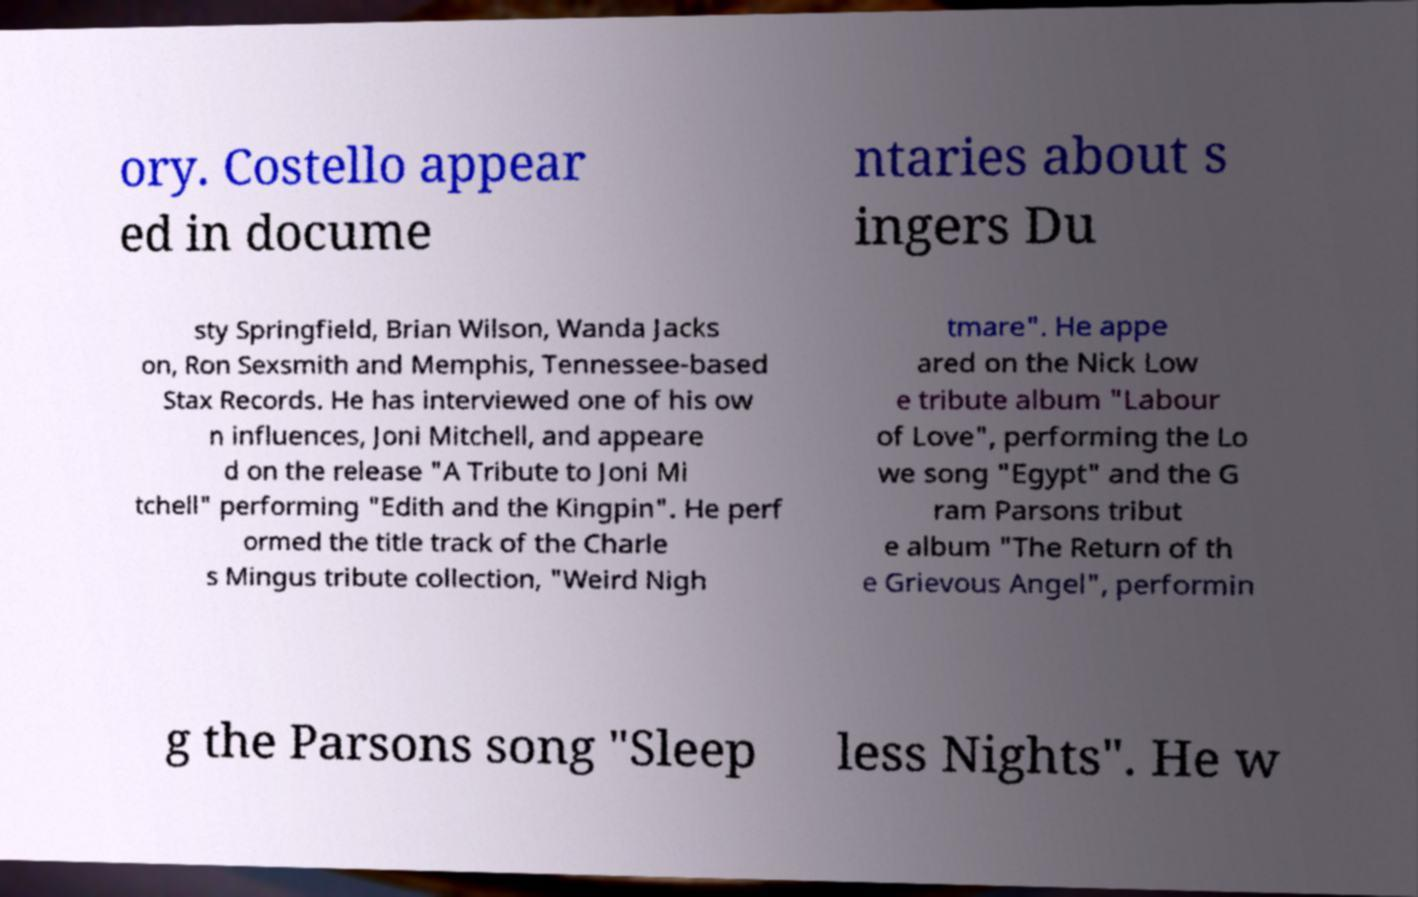For documentation purposes, I need the text within this image transcribed. Could you provide that? ory. Costello appear ed in docume ntaries about s ingers Du sty Springfield, Brian Wilson, Wanda Jacks on, Ron Sexsmith and Memphis, Tennessee-based Stax Records. He has interviewed one of his ow n influences, Joni Mitchell, and appeare d on the release "A Tribute to Joni Mi tchell" performing "Edith and the Kingpin". He perf ormed the title track of the Charle s Mingus tribute collection, "Weird Nigh tmare". He appe ared on the Nick Low e tribute album "Labour of Love", performing the Lo we song "Egypt" and the G ram Parsons tribut e album "The Return of th e Grievous Angel", performin g the Parsons song "Sleep less Nights". He w 